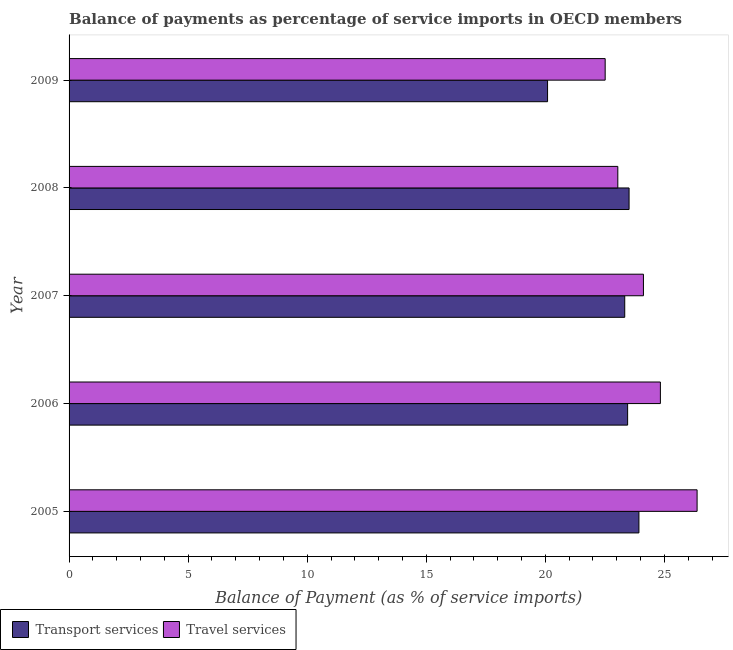How many different coloured bars are there?
Your answer should be compact. 2. Are the number of bars per tick equal to the number of legend labels?
Your response must be concise. Yes. Are the number of bars on each tick of the Y-axis equal?
Your answer should be compact. Yes. How many bars are there on the 1st tick from the top?
Provide a succinct answer. 2. What is the label of the 1st group of bars from the top?
Make the answer very short. 2009. What is the balance of payments of travel services in 2005?
Ensure brevity in your answer.  26.37. Across all years, what is the maximum balance of payments of travel services?
Ensure brevity in your answer.  26.37. Across all years, what is the minimum balance of payments of transport services?
Offer a very short reply. 20.09. What is the total balance of payments of transport services in the graph?
Your response must be concise. 114.33. What is the difference between the balance of payments of transport services in 2005 and that in 2008?
Give a very brief answer. 0.41. What is the difference between the balance of payments of travel services in 2008 and the balance of payments of transport services in 2009?
Provide a succinct answer. 2.95. What is the average balance of payments of transport services per year?
Offer a very short reply. 22.87. In the year 2005, what is the difference between the balance of payments of transport services and balance of payments of travel services?
Your response must be concise. -2.44. What is the ratio of the balance of payments of travel services in 2005 to that in 2007?
Offer a terse response. 1.09. Is the balance of payments of transport services in 2005 less than that in 2008?
Provide a short and direct response. No. Is the difference between the balance of payments of transport services in 2007 and 2009 greater than the difference between the balance of payments of travel services in 2007 and 2009?
Provide a short and direct response. Yes. What is the difference between the highest and the second highest balance of payments of transport services?
Your response must be concise. 0.41. What is the difference between the highest and the lowest balance of payments of transport services?
Your answer should be very brief. 3.84. In how many years, is the balance of payments of transport services greater than the average balance of payments of transport services taken over all years?
Offer a very short reply. 4. What does the 2nd bar from the top in 2005 represents?
Offer a very short reply. Transport services. What does the 1st bar from the bottom in 2008 represents?
Your answer should be compact. Transport services. How many bars are there?
Provide a succinct answer. 10. Are all the bars in the graph horizontal?
Your response must be concise. Yes. What is the difference between two consecutive major ticks on the X-axis?
Provide a short and direct response. 5. Are the values on the major ticks of X-axis written in scientific E-notation?
Offer a terse response. No. How many legend labels are there?
Ensure brevity in your answer.  2. How are the legend labels stacked?
Your response must be concise. Horizontal. What is the title of the graph?
Provide a succinct answer. Balance of payments as percentage of service imports in OECD members. Does "Stunting" appear as one of the legend labels in the graph?
Your response must be concise. No. What is the label or title of the X-axis?
Provide a succinct answer. Balance of Payment (as % of service imports). What is the label or title of the Y-axis?
Offer a terse response. Year. What is the Balance of Payment (as % of service imports) in Transport services in 2005?
Your response must be concise. 23.93. What is the Balance of Payment (as % of service imports) in Travel services in 2005?
Offer a terse response. 26.37. What is the Balance of Payment (as % of service imports) of Transport services in 2006?
Make the answer very short. 23.46. What is the Balance of Payment (as % of service imports) in Travel services in 2006?
Your answer should be compact. 24.83. What is the Balance of Payment (as % of service imports) in Transport services in 2007?
Your answer should be very brief. 23.33. What is the Balance of Payment (as % of service imports) of Travel services in 2007?
Your answer should be compact. 24.12. What is the Balance of Payment (as % of service imports) in Transport services in 2008?
Offer a terse response. 23.52. What is the Balance of Payment (as % of service imports) of Travel services in 2008?
Make the answer very short. 23.04. What is the Balance of Payment (as % of service imports) of Transport services in 2009?
Make the answer very short. 20.09. What is the Balance of Payment (as % of service imports) in Travel services in 2009?
Your response must be concise. 22.51. Across all years, what is the maximum Balance of Payment (as % of service imports) of Transport services?
Your response must be concise. 23.93. Across all years, what is the maximum Balance of Payment (as % of service imports) of Travel services?
Provide a short and direct response. 26.37. Across all years, what is the minimum Balance of Payment (as % of service imports) in Transport services?
Ensure brevity in your answer.  20.09. Across all years, what is the minimum Balance of Payment (as % of service imports) in Travel services?
Make the answer very short. 22.51. What is the total Balance of Payment (as % of service imports) of Transport services in the graph?
Your response must be concise. 114.33. What is the total Balance of Payment (as % of service imports) of Travel services in the graph?
Provide a short and direct response. 120.88. What is the difference between the Balance of Payment (as % of service imports) in Transport services in 2005 and that in 2006?
Give a very brief answer. 0.47. What is the difference between the Balance of Payment (as % of service imports) in Travel services in 2005 and that in 2006?
Provide a succinct answer. 1.54. What is the difference between the Balance of Payment (as % of service imports) in Transport services in 2005 and that in 2007?
Make the answer very short. 0.6. What is the difference between the Balance of Payment (as % of service imports) of Travel services in 2005 and that in 2007?
Your answer should be compact. 2.25. What is the difference between the Balance of Payment (as % of service imports) in Transport services in 2005 and that in 2008?
Ensure brevity in your answer.  0.41. What is the difference between the Balance of Payment (as % of service imports) in Travel services in 2005 and that in 2008?
Your response must be concise. 3.33. What is the difference between the Balance of Payment (as % of service imports) in Transport services in 2005 and that in 2009?
Offer a terse response. 3.84. What is the difference between the Balance of Payment (as % of service imports) in Travel services in 2005 and that in 2009?
Ensure brevity in your answer.  3.86. What is the difference between the Balance of Payment (as % of service imports) in Transport services in 2006 and that in 2007?
Your answer should be compact. 0.12. What is the difference between the Balance of Payment (as % of service imports) in Travel services in 2006 and that in 2007?
Give a very brief answer. 0.71. What is the difference between the Balance of Payment (as % of service imports) of Transport services in 2006 and that in 2008?
Offer a terse response. -0.06. What is the difference between the Balance of Payment (as % of service imports) of Travel services in 2006 and that in 2008?
Your answer should be very brief. 1.79. What is the difference between the Balance of Payment (as % of service imports) in Transport services in 2006 and that in 2009?
Keep it short and to the point. 3.36. What is the difference between the Balance of Payment (as % of service imports) in Travel services in 2006 and that in 2009?
Give a very brief answer. 2.32. What is the difference between the Balance of Payment (as % of service imports) of Transport services in 2007 and that in 2008?
Your answer should be very brief. -0.18. What is the difference between the Balance of Payment (as % of service imports) in Travel services in 2007 and that in 2008?
Provide a short and direct response. 1.08. What is the difference between the Balance of Payment (as % of service imports) of Transport services in 2007 and that in 2009?
Offer a terse response. 3.24. What is the difference between the Balance of Payment (as % of service imports) in Travel services in 2007 and that in 2009?
Provide a succinct answer. 1.61. What is the difference between the Balance of Payment (as % of service imports) of Transport services in 2008 and that in 2009?
Offer a terse response. 3.42. What is the difference between the Balance of Payment (as % of service imports) of Travel services in 2008 and that in 2009?
Offer a very short reply. 0.53. What is the difference between the Balance of Payment (as % of service imports) of Transport services in 2005 and the Balance of Payment (as % of service imports) of Travel services in 2006?
Offer a very short reply. -0.9. What is the difference between the Balance of Payment (as % of service imports) in Transport services in 2005 and the Balance of Payment (as % of service imports) in Travel services in 2007?
Your answer should be compact. -0.19. What is the difference between the Balance of Payment (as % of service imports) of Transport services in 2005 and the Balance of Payment (as % of service imports) of Travel services in 2008?
Offer a terse response. 0.89. What is the difference between the Balance of Payment (as % of service imports) in Transport services in 2005 and the Balance of Payment (as % of service imports) in Travel services in 2009?
Keep it short and to the point. 1.42. What is the difference between the Balance of Payment (as % of service imports) in Transport services in 2006 and the Balance of Payment (as % of service imports) in Travel services in 2007?
Offer a very short reply. -0.66. What is the difference between the Balance of Payment (as % of service imports) of Transport services in 2006 and the Balance of Payment (as % of service imports) of Travel services in 2008?
Offer a terse response. 0.41. What is the difference between the Balance of Payment (as % of service imports) in Transport services in 2006 and the Balance of Payment (as % of service imports) in Travel services in 2009?
Give a very brief answer. 0.94. What is the difference between the Balance of Payment (as % of service imports) of Transport services in 2007 and the Balance of Payment (as % of service imports) of Travel services in 2008?
Ensure brevity in your answer.  0.29. What is the difference between the Balance of Payment (as % of service imports) of Transport services in 2007 and the Balance of Payment (as % of service imports) of Travel services in 2009?
Offer a very short reply. 0.82. What is the difference between the Balance of Payment (as % of service imports) of Transport services in 2008 and the Balance of Payment (as % of service imports) of Travel services in 2009?
Ensure brevity in your answer.  1. What is the average Balance of Payment (as % of service imports) of Transport services per year?
Provide a succinct answer. 22.87. What is the average Balance of Payment (as % of service imports) of Travel services per year?
Offer a terse response. 24.18. In the year 2005, what is the difference between the Balance of Payment (as % of service imports) of Transport services and Balance of Payment (as % of service imports) of Travel services?
Ensure brevity in your answer.  -2.44. In the year 2006, what is the difference between the Balance of Payment (as % of service imports) of Transport services and Balance of Payment (as % of service imports) of Travel services?
Your response must be concise. -1.38. In the year 2007, what is the difference between the Balance of Payment (as % of service imports) in Transport services and Balance of Payment (as % of service imports) in Travel services?
Provide a short and direct response. -0.79. In the year 2008, what is the difference between the Balance of Payment (as % of service imports) in Transport services and Balance of Payment (as % of service imports) in Travel services?
Your answer should be compact. 0.47. In the year 2009, what is the difference between the Balance of Payment (as % of service imports) of Transport services and Balance of Payment (as % of service imports) of Travel services?
Keep it short and to the point. -2.42. What is the ratio of the Balance of Payment (as % of service imports) in Transport services in 2005 to that in 2006?
Your response must be concise. 1.02. What is the ratio of the Balance of Payment (as % of service imports) in Travel services in 2005 to that in 2006?
Your answer should be compact. 1.06. What is the ratio of the Balance of Payment (as % of service imports) in Transport services in 2005 to that in 2007?
Ensure brevity in your answer.  1.03. What is the ratio of the Balance of Payment (as % of service imports) in Travel services in 2005 to that in 2007?
Offer a very short reply. 1.09. What is the ratio of the Balance of Payment (as % of service imports) of Transport services in 2005 to that in 2008?
Provide a succinct answer. 1.02. What is the ratio of the Balance of Payment (as % of service imports) of Travel services in 2005 to that in 2008?
Ensure brevity in your answer.  1.14. What is the ratio of the Balance of Payment (as % of service imports) in Transport services in 2005 to that in 2009?
Your response must be concise. 1.19. What is the ratio of the Balance of Payment (as % of service imports) in Travel services in 2005 to that in 2009?
Your answer should be compact. 1.17. What is the ratio of the Balance of Payment (as % of service imports) of Transport services in 2006 to that in 2007?
Provide a succinct answer. 1.01. What is the ratio of the Balance of Payment (as % of service imports) in Travel services in 2006 to that in 2007?
Ensure brevity in your answer.  1.03. What is the ratio of the Balance of Payment (as % of service imports) in Travel services in 2006 to that in 2008?
Offer a terse response. 1.08. What is the ratio of the Balance of Payment (as % of service imports) of Transport services in 2006 to that in 2009?
Make the answer very short. 1.17. What is the ratio of the Balance of Payment (as % of service imports) of Travel services in 2006 to that in 2009?
Your answer should be compact. 1.1. What is the ratio of the Balance of Payment (as % of service imports) of Transport services in 2007 to that in 2008?
Offer a terse response. 0.99. What is the ratio of the Balance of Payment (as % of service imports) of Travel services in 2007 to that in 2008?
Provide a short and direct response. 1.05. What is the ratio of the Balance of Payment (as % of service imports) of Transport services in 2007 to that in 2009?
Offer a terse response. 1.16. What is the ratio of the Balance of Payment (as % of service imports) in Travel services in 2007 to that in 2009?
Ensure brevity in your answer.  1.07. What is the ratio of the Balance of Payment (as % of service imports) of Transport services in 2008 to that in 2009?
Your response must be concise. 1.17. What is the ratio of the Balance of Payment (as % of service imports) in Travel services in 2008 to that in 2009?
Offer a very short reply. 1.02. What is the difference between the highest and the second highest Balance of Payment (as % of service imports) in Transport services?
Your answer should be very brief. 0.41. What is the difference between the highest and the second highest Balance of Payment (as % of service imports) of Travel services?
Provide a short and direct response. 1.54. What is the difference between the highest and the lowest Balance of Payment (as % of service imports) in Transport services?
Your answer should be compact. 3.84. What is the difference between the highest and the lowest Balance of Payment (as % of service imports) of Travel services?
Keep it short and to the point. 3.86. 